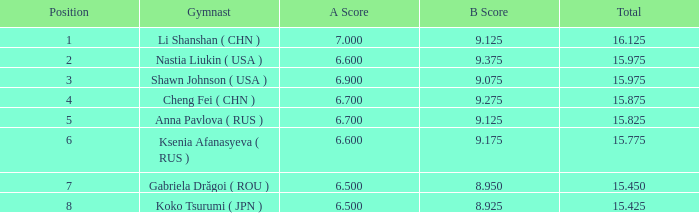What's the total that the position is less than 1? None. Could you parse the entire table as a dict? {'header': ['Position', 'Gymnast', 'A Score', 'B Score', 'Total'], 'rows': [['1', 'Li Shanshan ( CHN )', '7.000', '9.125', '16.125'], ['2', 'Nastia Liukin ( USA )', '6.600', '9.375', '15.975'], ['3', 'Shawn Johnson ( USA )', '6.900', '9.075', '15.975'], ['4', 'Cheng Fei ( CHN )', '6.700', '9.275', '15.875'], ['5', 'Anna Pavlova ( RUS )', '6.700', '9.125', '15.825'], ['6', 'Ksenia Afanasyeva ( RUS )', '6.600', '9.175', '15.775'], ['7', 'Gabriela Drăgoi ( ROU )', '6.500', '8.950', '15.450'], ['8', 'Koko Tsurumi ( JPN )', '6.500', '8.925', '15.425']]} 